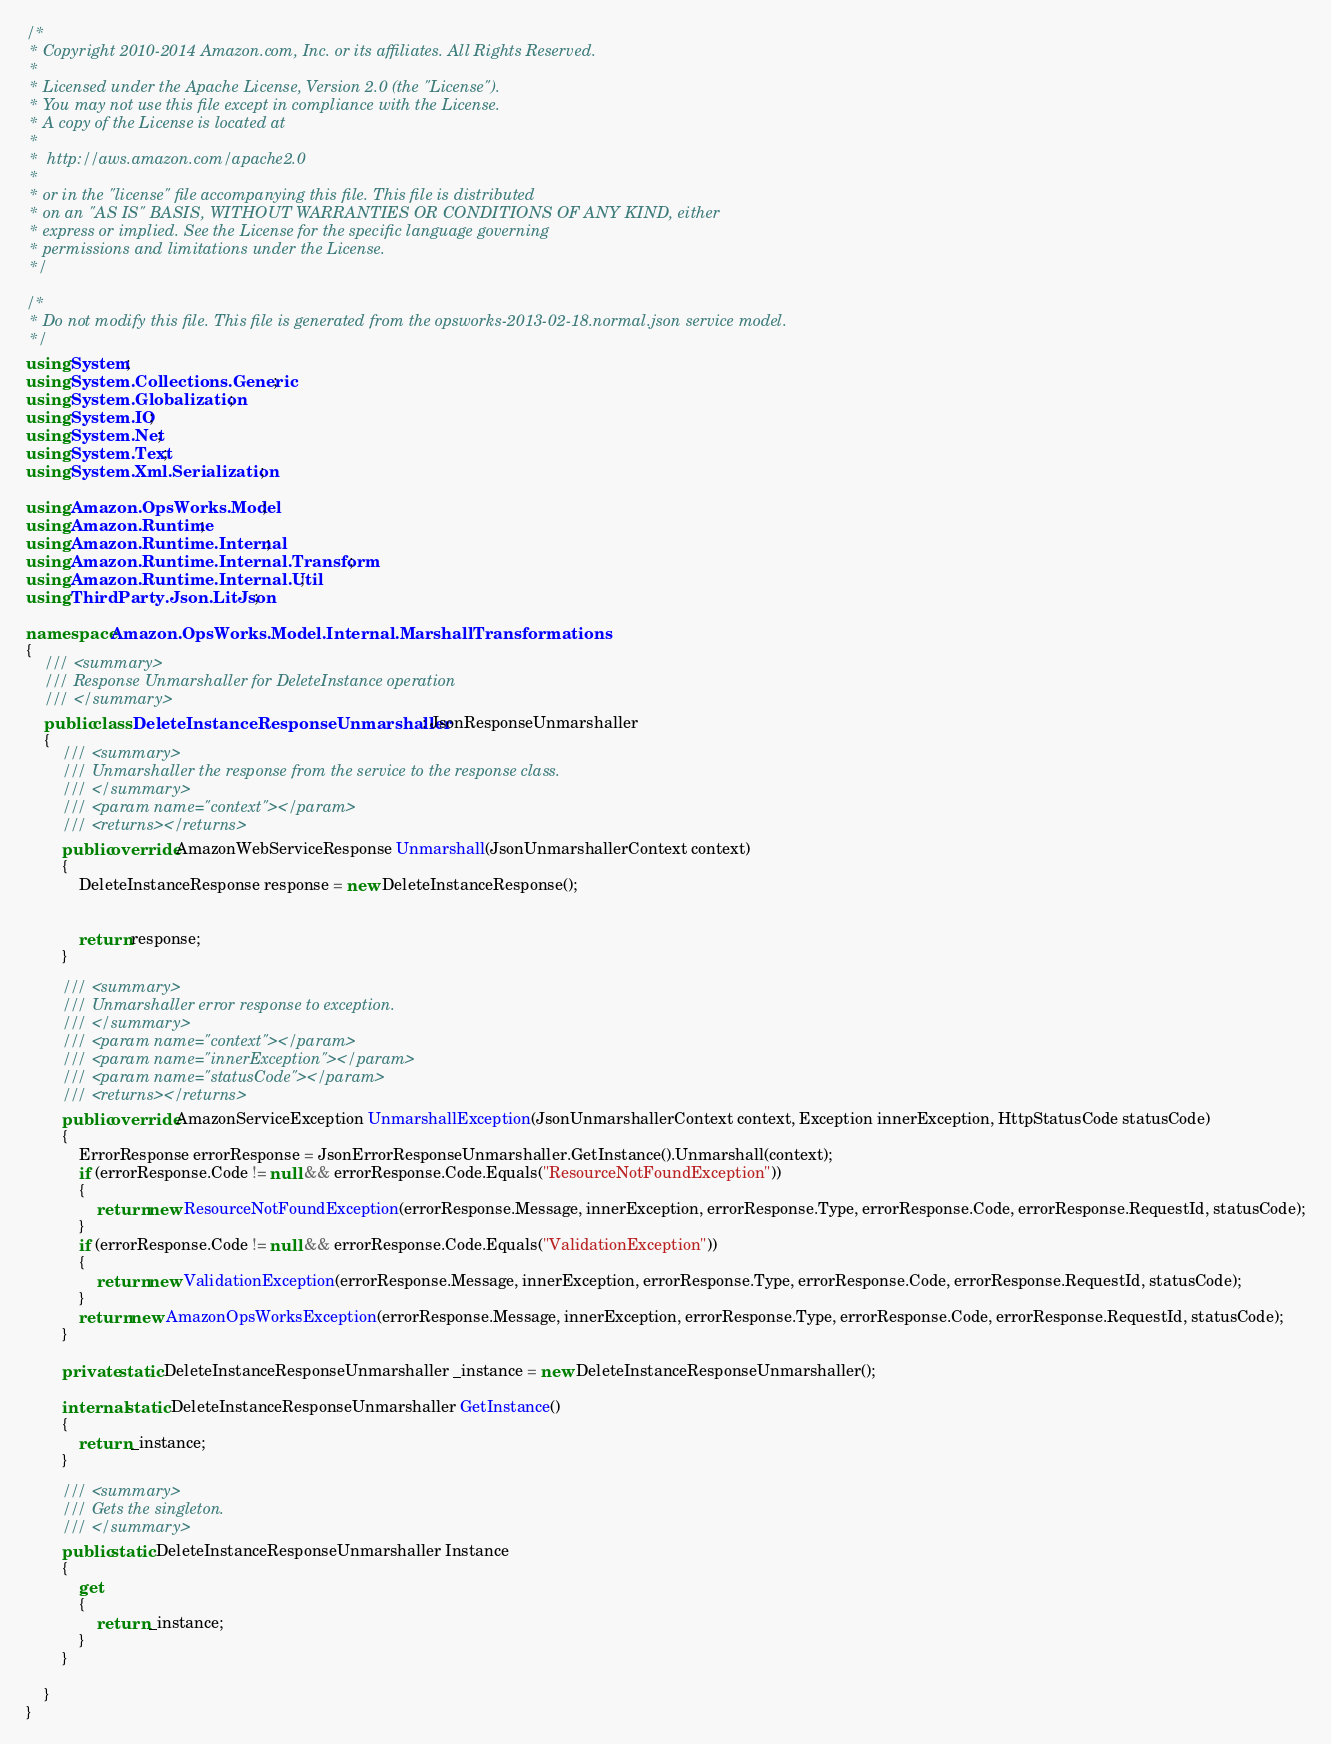Convert code to text. <code><loc_0><loc_0><loc_500><loc_500><_C#_>/*
 * Copyright 2010-2014 Amazon.com, Inc. or its affiliates. All Rights Reserved.
 * 
 * Licensed under the Apache License, Version 2.0 (the "License").
 * You may not use this file except in compliance with the License.
 * A copy of the License is located at
 * 
 *  http://aws.amazon.com/apache2.0
 * 
 * or in the "license" file accompanying this file. This file is distributed
 * on an "AS IS" BASIS, WITHOUT WARRANTIES OR CONDITIONS OF ANY KIND, either
 * express or implied. See the License for the specific language governing
 * permissions and limitations under the License.
 */

/*
 * Do not modify this file. This file is generated from the opsworks-2013-02-18.normal.json service model.
 */
using System;
using System.Collections.Generic;
using System.Globalization;
using System.IO;
using System.Net;
using System.Text;
using System.Xml.Serialization;

using Amazon.OpsWorks.Model;
using Amazon.Runtime;
using Amazon.Runtime.Internal;
using Amazon.Runtime.Internal.Transform;
using Amazon.Runtime.Internal.Util;
using ThirdParty.Json.LitJson;

namespace Amazon.OpsWorks.Model.Internal.MarshallTransformations
{
    /// <summary>
    /// Response Unmarshaller for DeleteInstance operation
    /// </summary>  
    public class DeleteInstanceResponseUnmarshaller : JsonResponseUnmarshaller
    {
        /// <summary>
        /// Unmarshaller the response from the service to the response class.
        /// </summary>  
        /// <param name="context"></param>
        /// <returns></returns>
        public override AmazonWebServiceResponse Unmarshall(JsonUnmarshallerContext context)
        {
            DeleteInstanceResponse response = new DeleteInstanceResponse();


            return response;
        }

        /// <summary>
        /// Unmarshaller error response to exception.
        /// </summary>  
        /// <param name="context"></param>
        /// <param name="innerException"></param>
        /// <param name="statusCode"></param>
        /// <returns></returns>
        public override AmazonServiceException UnmarshallException(JsonUnmarshallerContext context, Exception innerException, HttpStatusCode statusCode)
        {
            ErrorResponse errorResponse = JsonErrorResponseUnmarshaller.GetInstance().Unmarshall(context);
            if (errorResponse.Code != null && errorResponse.Code.Equals("ResourceNotFoundException"))
            {
                return new ResourceNotFoundException(errorResponse.Message, innerException, errorResponse.Type, errorResponse.Code, errorResponse.RequestId, statusCode);
            }
            if (errorResponse.Code != null && errorResponse.Code.Equals("ValidationException"))
            {
                return new ValidationException(errorResponse.Message, innerException, errorResponse.Type, errorResponse.Code, errorResponse.RequestId, statusCode);
            }
            return new AmazonOpsWorksException(errorResponse.Message, innerException, errorResponse.Type, errorResponse.Code, errorResponse.RequestId, statusCode);
        }

        private static DeleteInstanceResponseUnmarshaller _instance = new DeleteInstanceResponseUnmarshaller();        

        internal static DeleteInstanceResponseUnmarshaller GetInstance()
        {
            return _instance;
        }

        /// <summary>
        /// Gets the singleton.
        /// </summary>  
        public static DeleteInstanceResponseUnmarshaller Instance
        {
            get
            {
                return _instance;
            }
        }

    }
}</code> 